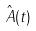Convert formula to latex. <formula><loc_0><loc_0><loc_500><loc_500>\hat { A } ( t )</formula> 